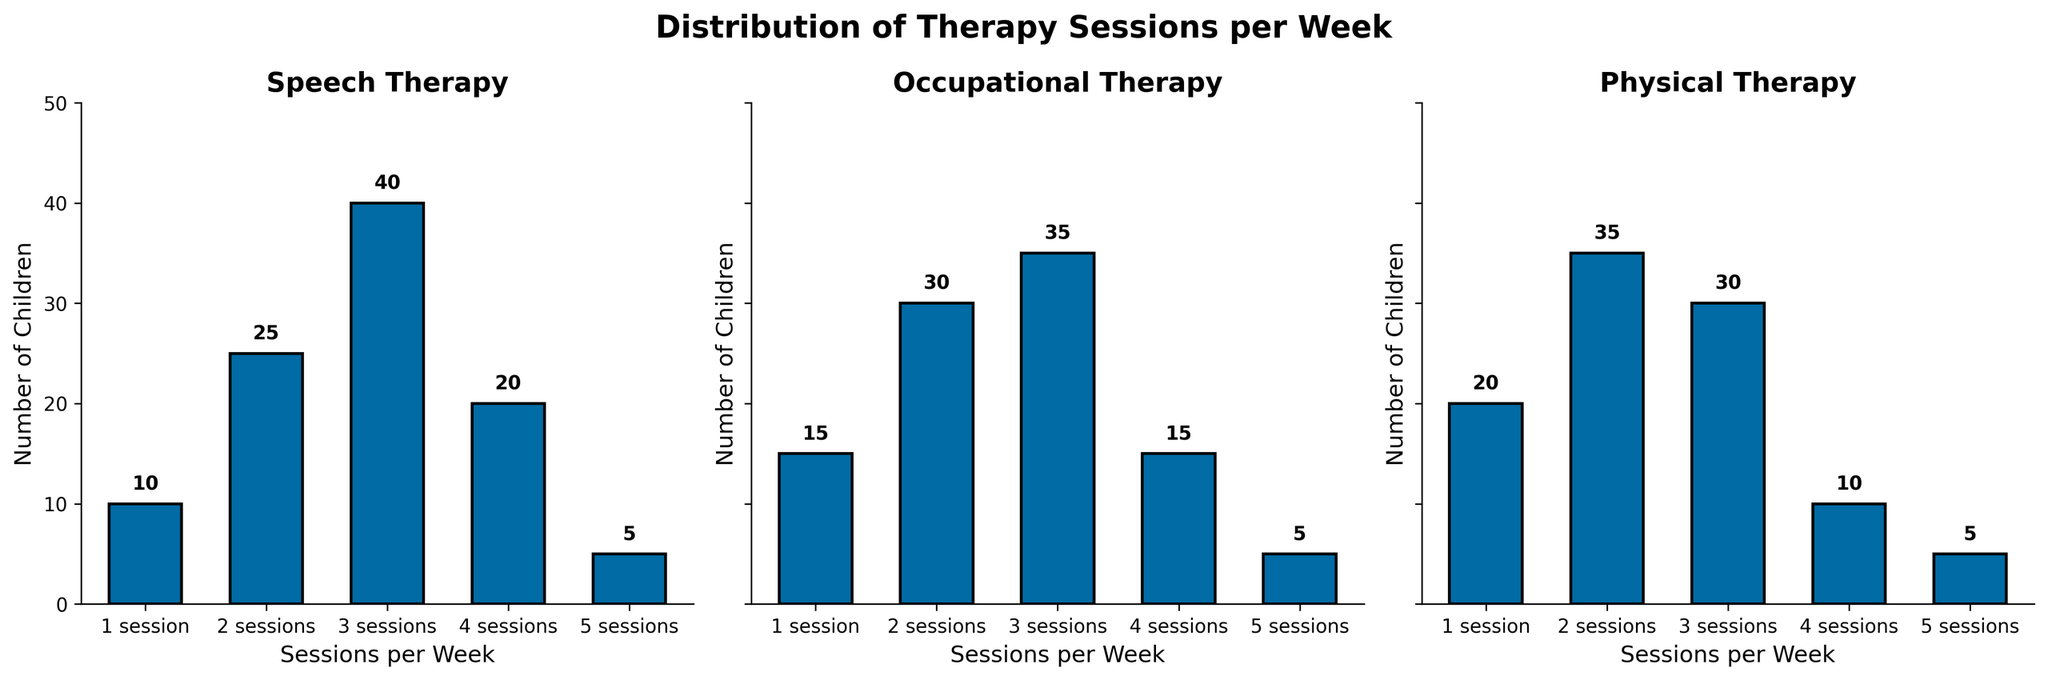How many children attend exactly 3 sessions of Speech Therapy per week? Referring to the Speech Therapy subplot, the bar for '3 sessions' is labeled with the value 40, indicating 40 children attend exactly 3 sessions per week.
Answer: 40 Which therapy has the highest number of children attending 4 sessions per week? In the subplots, the values for 4 sessions are Speech Therapy: 20, Occupational Therapy: 15, Physical Therapy: 10. Therefore, Speech Therapy has the highest number of children attending 4 sessions per week.
Answer: Speech Therapy What is the total number of children receiving Occupational Therapy across all sessions per week? The values for Occupational Therapy across all sessions are 15, 30, 35, 15, and 5. Summing these values gives the total number of children: 15 + 30 + 35 + 15 + 5 = 100.
Answer: 100 How many more children attend 1 session per week of Physical Therapy compared to Speech Therapy? The subplot for 1 session shows Physical Therapy has 20 children, and Speech Therapy has 10 children. The difference is 20 - 10 = 10.
Answer: 10 Which session frequency has the lowest number of children in Physical Therapy? Referring to the Physical Therapy subplot, the values for each session frequency are 20, 35, 30, 10, and 5. The lowest number corresponds to 5 sessions per week.
Answer: 5 sessions What is the average number of children per session for Speech Therapy? The values for Speech Therapy sessions are 10, 25, 40, 20, and 5. Summing these values gives 10 + 25 + 40 + 20 + 5 = 100 and dividing by 5 (the number of session options) gives an average of 100 / 5 = 20.
Answer: 20 How does the distribution of children attending 2 sessions per week compare between Speech Therapy and Occupational Therapy? For 2 sessions per week, Speech Therapy has 25 children, while Occupational Therapy has 30 children. Comparing these values shows that Occupational Therapy has 5 more children attending 2 sessions per week than Speech Therapy.
Answer: Occupational Therapy has 5 more Which therapy has the most evenly distributed attendance across different session frequencies? Even distribution can be inferred from the subplot where the heights of the bars are relatively similar. Upon examining the subplots, Occupational Therapy shows the most even distribution with values 15, 30, 35, 15, and 5, while Speech Therapy and Physical Therapy have greater differences between values.
Answer: Occupational Therapy What is the median number of children attending 4 sessions per week across all therapies? The values for 4 sessions per week are: Speech Therapy: 20, Occupational Therapy: 15, Physical Therapy: 10. When ordered (10, 15, 20), the median value is the middle value, which is 15.
Answer: 15 